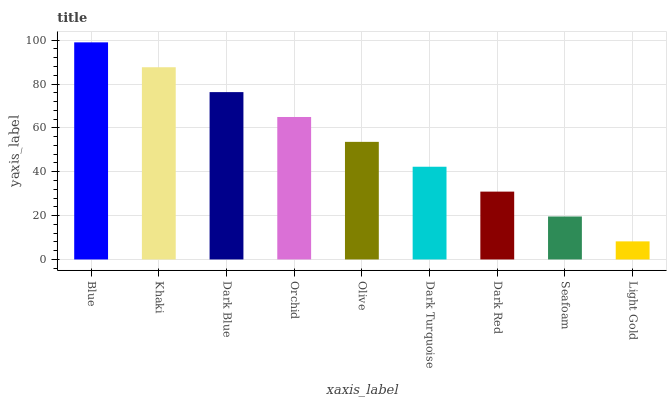Is Light Gold the minimum?
Answer yes or no. Yes. Is Blue the maximum?
Answer yes or no. Yes. Is Khaki the minimum?
Answer yes or no. No. Is Khaki the maximum?
Answer yes or no. No. Is Blue greater than Khaki?
Answer yes or no. Yes. Is Khaki less than Blue?
Answer yes or no. Yes. Is Khaki greater than Blue?
Answer yes or no. No. Is Blue less than Khaki?
Answer yes or no. No. Is Olive the high median?
Answer yes or no. Yes. Is Olive the low median?
Answer yes or no. Yes. Is Khaki the high median?
Answer yes or no. No. Is Light Gold the low median?
Answer yes or no. No. 